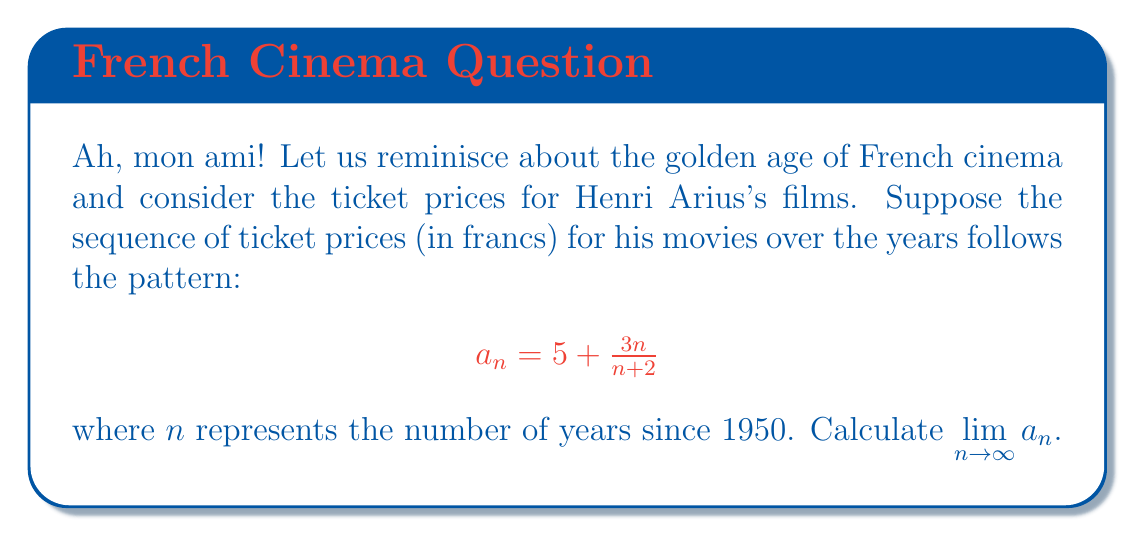Can you solve this math problem? Let's approach this step-by-step, mon cher:

1) First, we need to analyze the behavior of the sequence as $n$ approaches infinity:

   $$\lim_{n \to \infty} a_n = \lim_{n \to \infty} \left(5 + \frac{3n}{n+2}\right)$$

2) We can split this limit:

   $$\lim_{n \to \infty} 5 + \lim_{n \to \infty} \frac{3n}{n+2}$$

3) The first term is constant, so:

   $$5 + \lim_{n \to \infty} \frac{3n}{n+2}$$

4) For the second term, let's divide both numerator and denominator by $n$:

   $$5 + \lim_{n \to \infty} \frac{3}{\frac{n+2}{n}} = 5 + \lim_{n \to \infty} \frac{3}{1 + \frac{2}{n}}$$

5) As $n$ approaches infinity, $\frac{2}{n}$ approaches 0:

   $$5 + \frac{3}{1 + 0} = 5 + 3 = 8$$

Thus, the ticket prices would asymptotically approach 8 francs.
Answer: 8 